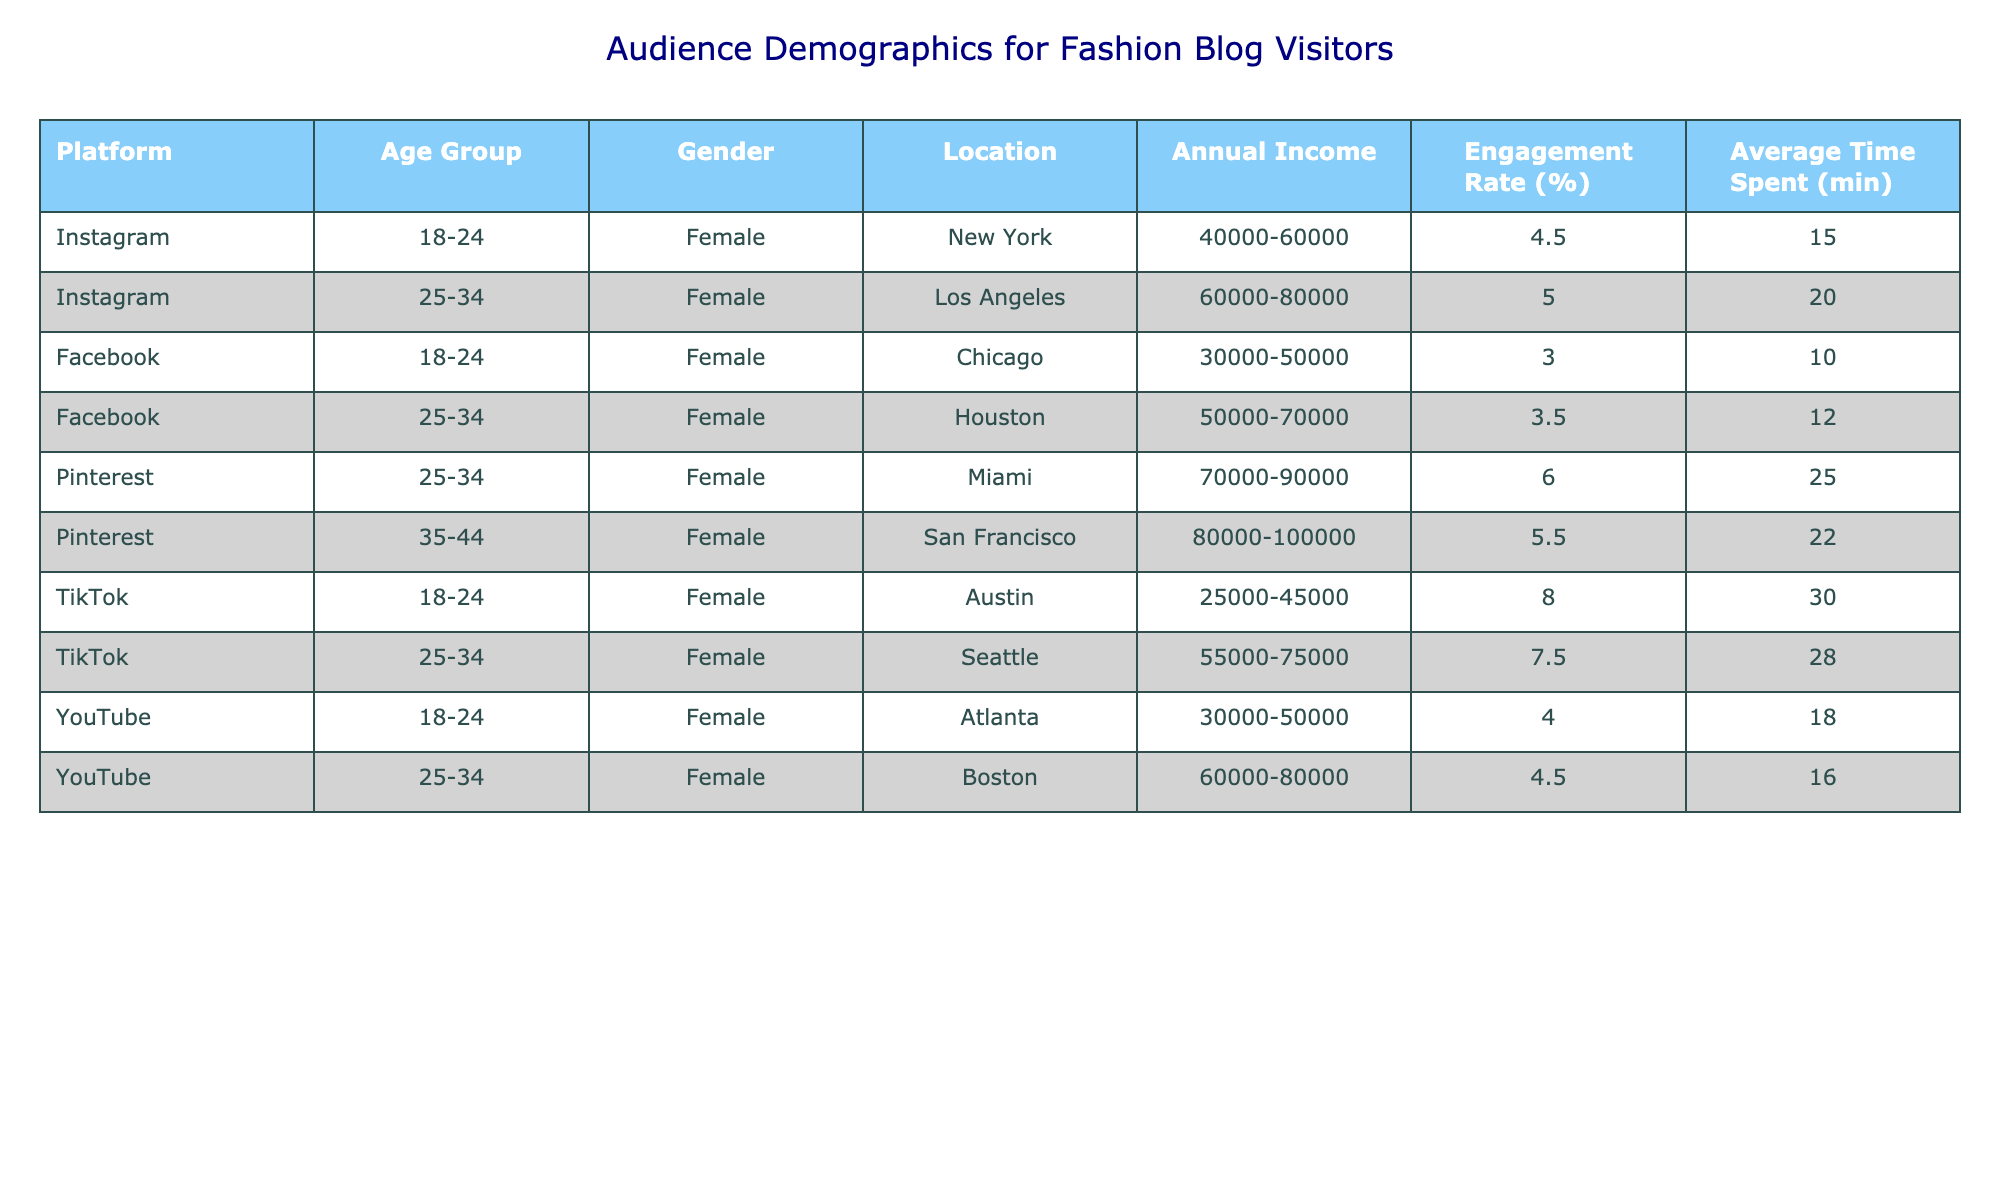What is the engagement rate for TikTok users aged 18-24? The table shows that for TikTok users in the age group 18-24, the engagement rate is listed as 8.0%.
Answer: 8.0% Which platform has the highest average time spent by visitors? Looking at the "Average Time Spent" column, TikTok users aged 18-24 spend the most time at 30 minutes. No other platform has a value higher than this.
Answer: TikTok What is the annual income range of Instagram visitors aged 25-34? The table indicates that Instagram visitors in the age group 25-34 have an annual income range of 60,000 to 80,000.
Answer: 60,000-80,000 Is there a gender difference in the engagement rates for Facebook users across the two age groups listed? For Facebook, the engagement rates are 3.0% for users aged 18-24 and 3.5% for users aged 25-34, both being female and relatively low. There is a slight increase in engagement rate but not significant.
Answer: Yes, slight increase What is the average engagement rate across all platforms for female users aged 25-34? To find the average, we look at the engagement rates for this age group: Instagram is 5.0%, Facebook is 3.5%, Pinterest is 6.0%, TikTok is 7.5%, and YouTube is 4.5%. Summing these values gives: 5.0 + 3.5 + 6.0 + 7.5 + 4.5 = 26.5. Dividing by 5 gives the average engagement rate of 5.3%.
Answer: 5.3% Which location has the highest annual income range among Pinterest users? From the table, Pinterest users aged 25-34 are located in Miami, with an annual income range of 70,000 to 90,000. The 35-44 age group for Pinterest is based in San Francisco with an income of 80,000 to 100,000, which is higher.
Answer: San Francisco What is the location for TikTok users aged 25-34 with an annual income of 55,000-75,000? For TikTok users in the age group 25-34, the listed location is Seattle, which fits the specified income range of 55,000 to 75,000.
Answer: Seattle How many users on Facebook have an engagement rate below 4%? Analyzing the Facebook data, we observe that there are two entries: 3.0% for ages 18-24 and 3.5% for ages 25-34, meaning both have engagement rates below 4%. Therefore, there are 2 users.
Answer: 2 What can be inferred about the average time spent by the oldest age group (35-44) on Pinterest versus the youngest (18-24) on TikTok? The average time spent by Pinterest users aged 35-44 is 22 minutes, while users aged 18-24 on TikTok spend 30 minutes. This indicates that the younger group spends significantly more time on their platform.
Answer: Younger group spends more time 